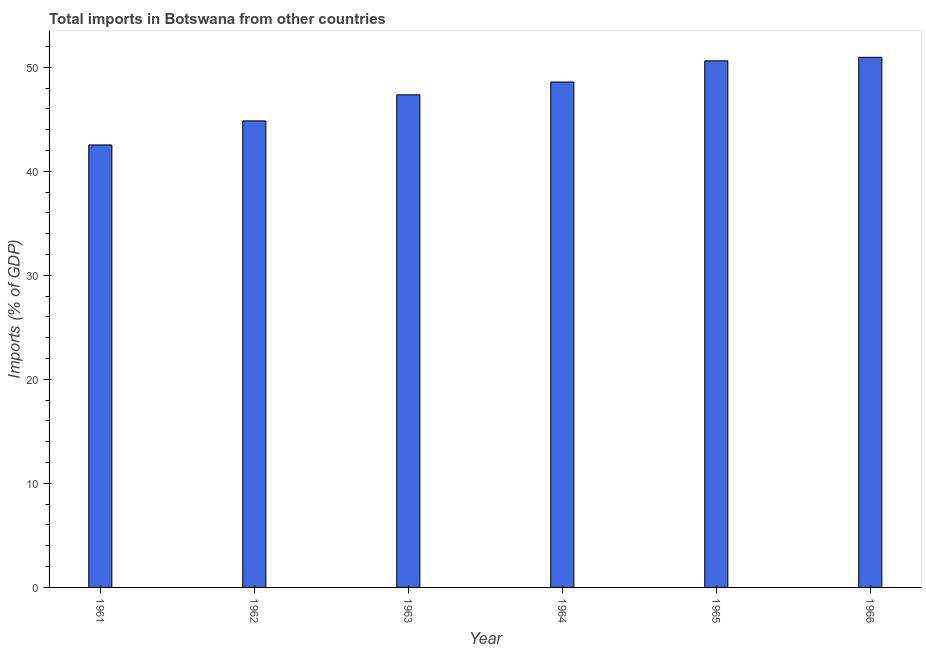Does the graph contain any zero values?
Give a very brief answer. No. Does the graph contain grids?
Your answer should be compact. No. What is the title of the graph?
Provide a succinct answer. Total imports in Botswana from other countries. What is the label or title of the X-axis?
Provide a short and direct response. Year. What is the label or title of the Y-axis?
Provide a succinct answer. Imports (% of GDP). What is the total imports in 1962?
Make the answer very short. 44.84. Across all years, what is the maximum total imports?
Your answer should be very brief. 50.95. Across all years, what is the minimum total imports?
Keep it short and to the point. 42.53. In which year was the total imports maximum?
Your response must be concise. 1966. What is the sum of the total imports?
Your response must be concise. 284.84. What is the difference between the total imports in 1961 and 1964?
Keep it short and to the point. -6.05. What is the average total imports per year?
Provide a succinct answer. 47.47. What is the median total imports?
Ensure brevity in your answer.  47.96. In how many years, is the total imports greater than 18 %?
Provide a short and direct response. 6. What is the ratio of the total imports in 1962 to that in 1965?
Provide a short and direct response. 0.89. What is the difference between the highest and the second highest total imports?
Your answer should be very brief. 0.34. What is the difference between the highest and the lowest total imports?
Your answer should be compact. 8.42. In how many years, is the total imports greater than the average total imports taken over all years?
Your answer should be very brief. 3. How many bars are there?
Provide a succinct answer. 6. What is the Imports (% of GDP) in 1961?
Give a very brief answer. 42.53. What is the Imports (% of GDP) in 1962?
Offer a terse response. 44.84. What is the Imports (% of GDP) in 1963?
Your answer should be compact. 47.35. What is the Imports (% of GDP) in 1964?
Provide a short and direct response. 48.58. What is the Imports (% of GDP) of 1965?
Your response must be concise. 50.61. What is the Imports (% of GDP) in 1966?
Offer a terse response. 50.95. What is the difference between the Imports (% of GDP) in 1961 and 1962?
Provide a short and direct response. -2.31. What is the difference between the Imports (% of GDP) in 1961 and 1963?
Provide a succinct answer. -4.82. What is the difference between the Imports (% of GDP) in 1961 and 1964?
Your answer should be compact. -6.05. What is the difference between the Imports (% of GDP) in 1961 and 1965?
Provide a short and direct response. -8.08. What is the difference between the Imports (% of GDP) in 1961 and 1966?
Your response must be concise. -8.42. What is the difference between the Imports (% of GDP) in 1962 and 1963?
Keep it short and to the point. -2.51. What is the difference between the Imports (% of GDP) in 1962 and 1964?
Your response must be concise. -3.74. What is the difference between the Imports (% of GDP) in 1962 and 1965?
Your answer should be compact. -5.77. What is the difference between the Imports (% of GDP) in 1962 and 1966?
Your response must be concise. -6.11. What is the difference between the Imports (% of GDP) in 1963 and 1964?
Keep it short and to the point. -1.23. What is the difference between the Imports (% of GDP) in 1963 and 1965?
Your answer should be very brief. -3.26. What is the difference between the Imports (% of GDP) in 1963 and 1966?
Offer a very short reply. -3.6. What is the difference between the Imports (% of GDP) in 1964 and 1965?
Offer a very short reply. -2.03. What is the difference between the Imports (% of GDP) in 1964 and 1966?
Your response must be concise. -2.37. What is the difference between the Imports (% of GDP) in 1965 and 1966?
Make the answer very short. -0.34. What is the ratio of the Imports (% of GDP) in 1961 to that in 1962?
Offer a terse response. 0.95. What is the ratio of the Imports (% of GDP) in 1961 to that in 1963?
Your response must be concise. 0.9. What is the ratio of the Imports (% of GDP) in 1961 to that in 1964?
Your answer should be compact. 0.88. What is the ratio of the Imports (% of GDP) in 1961 to that in 1965?
Provide a succinct answer. 0.84. What is the ratio of the Imports (% of GDP) in 1961 to that in 1966?
Provide a succinct answer. 0.83. What is the ratio of the Imports (% of GDP) in 1962 to that in 1963?
Your response must be concise. 0.95. What is the ratio of the Imports (% of GDP) in 1962 to that in 1964?
Provide a short and direct response. 0.92. What is the ratio of the Imports (% of GDP) in 1962 to that in 1965?
Offer a very short reply. 0.89. What is the ratio of the Imports (% of GDP) in 1963 to that in 1965?
Ensure brevity in your answer.  0.94. What is the ratio of the Imports (% of GDP) in 1963 to that in 1966?
Ensure brevity in your answer.  0.93. What is the ratio of the Imports (% of GDP) in 1964 to that in 1966?
Keep it short and to the point. 0.95. 